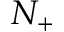<formula> <loc_0><loc_0><loc_500><loc_500>N _ { + }</formula> 